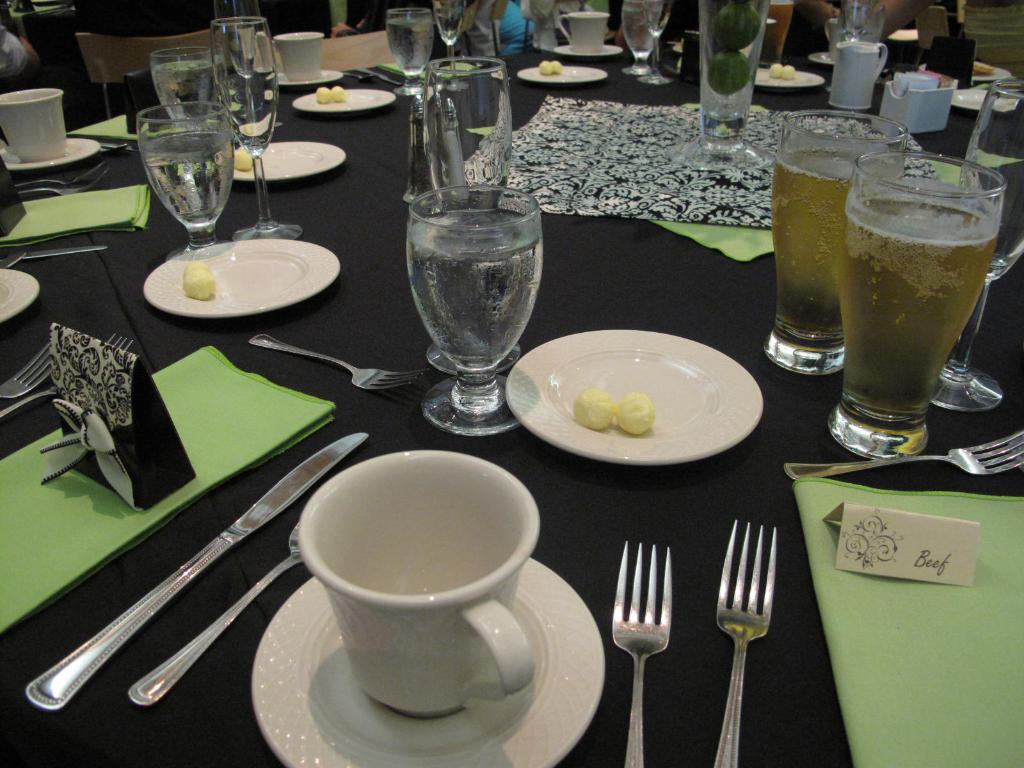What type of beverages are in the glasses on the table? There are glasses of wine and glasses of water on the table. What other types of tableware are present on the table? There are cups, forks, a butter knife, and plates on the table. Can you see any yaks grazing in the cemetery near the table? There is no cemetery or yaks present in the image; it only shows a table with various tableware and beverages. 